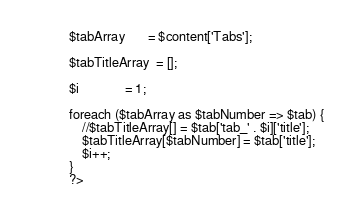Convert code to text. <code><loc_0><loc_0><loc_500><loc_500><_PHP_>            $tabArray		= $content['Tabs'];
            
            $tabTitleArray	= [];
            
            $i				= 1;
            
            foreach ($tabArray as $tabNumber => $tab) {
            	//$tabTitleArray[] = $tab['tab_' . $i]['title'];
            	$tabTitleArray[$tabNumber] = $tab['title'];
            	$i++;
            }
            ?></code> 